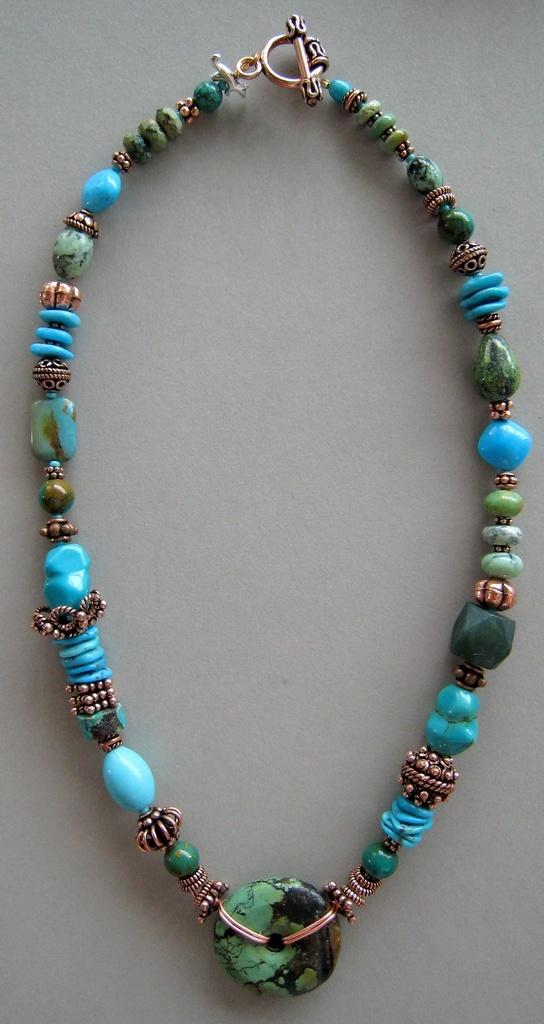What type of accessory is visible in the image? There is a necklace in the image. What can be seen in the background of the image? The background of the image features a plane. What rule is being enforced by the earth in the image? There is no reference to a rule or the earth in the image; it only features a necklace and a plane in the background. 